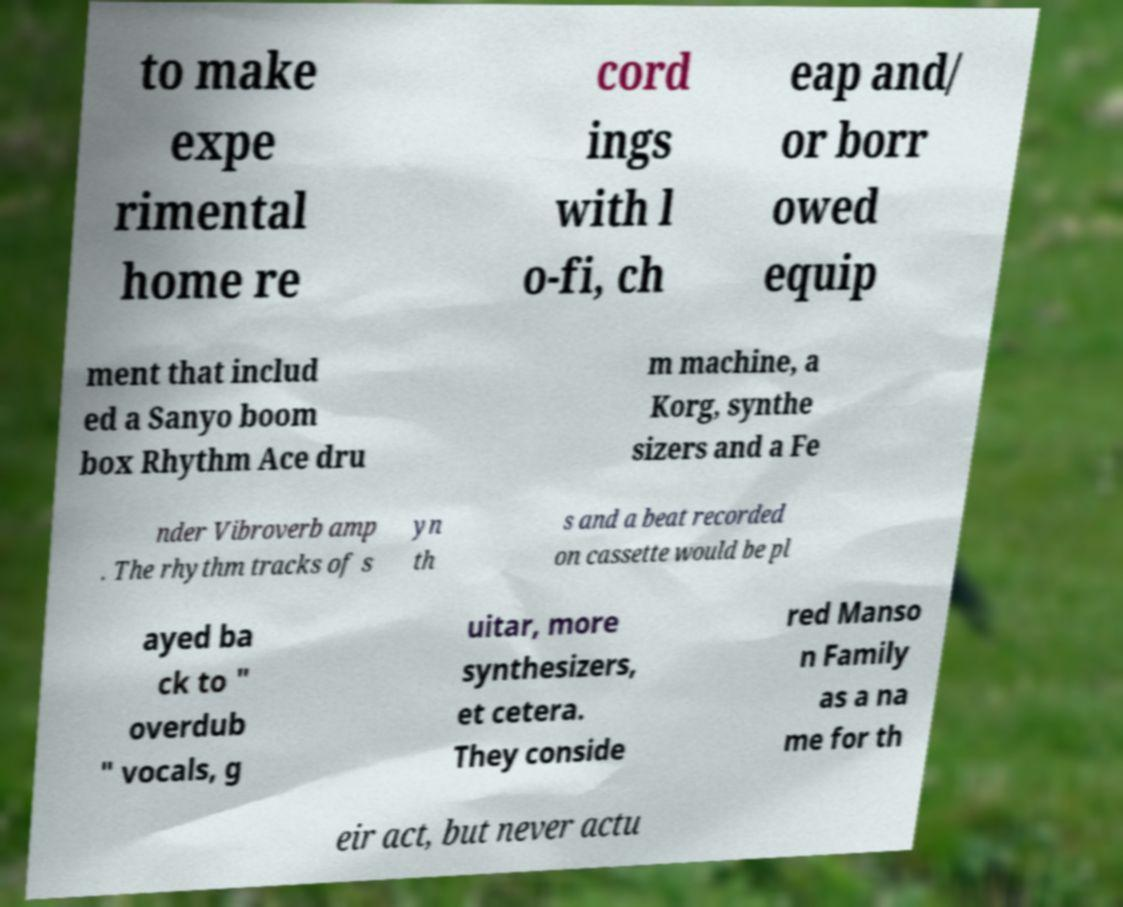Can you accurately transcribe the text from the provided image for me? to make expe rimental home re cord ings with l o-fi, ch eap and/ or borr owed equip ment that includ ed a Sanyo boom box Rhythm Ace dru m machine, a Korg, synthe sizers and a Fe nder Vibroverb amp . The rhythm tracks of s yn th s and a beat recorded on cassette would be pl ayed ba ck to " overdub " vocals, g uitar, more synthesizers, et cetera. They conside red Manso n Family as a na me for th eir act, but never actu 